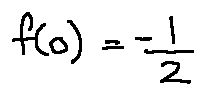Convert formula to latex. <formula><loc_0><loc_0><loc_500><loc_500>f ( 0 ) = - \frac { 1 } { 2 }</formula> 